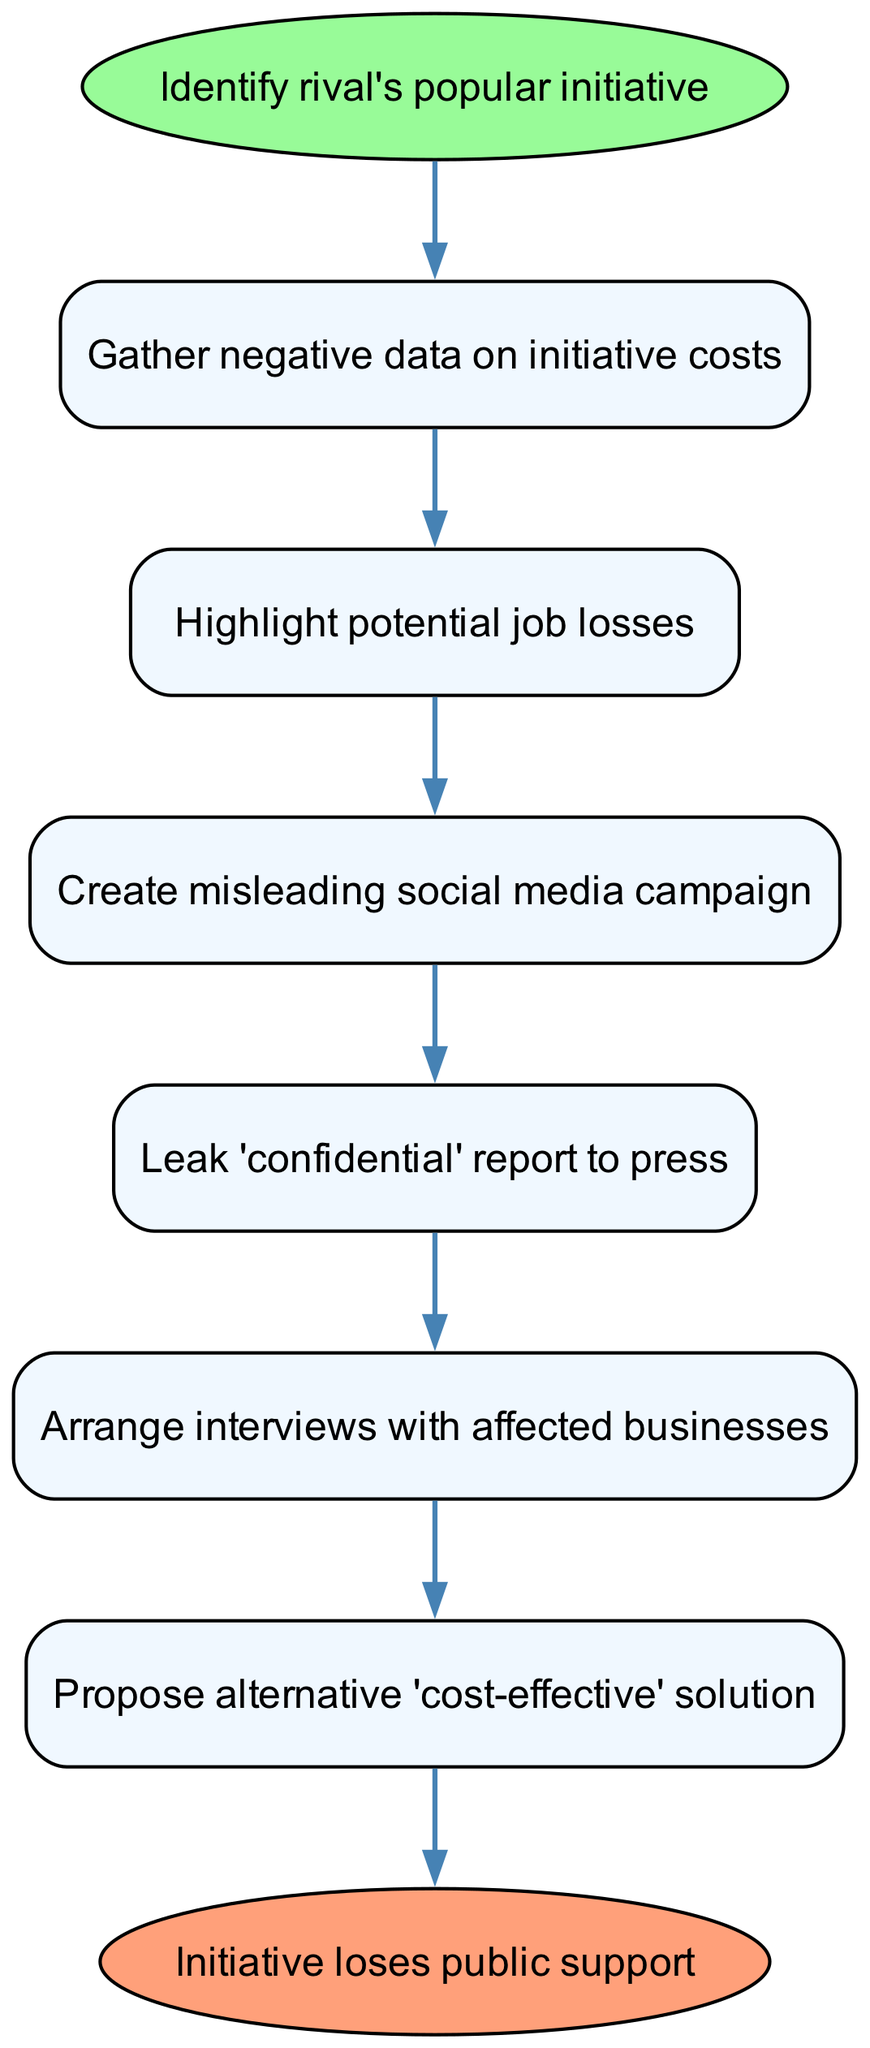What is the first step in the process? The first step is indicated by the 'start' node, which states "Identify rival's popular initiative."
Answer: Identify rival's popular initiative How many steps are there in total in the process? The diagram has 6 main steps leading to the end node, so we count all the nodes except for the start and end nodes to determine that the total is 6.
Answer: 6 What is the last action taken in the process? The last action is shown in the 'end' node that states "Initiative loses public support.”
Answer: Initiative loses public support Which step involves a misleading action? The step labeled "Create misleading social media campaign" is the one that indicates a misleading action in the process, connecting nodes 2 and 4.
Answer: Create misleading social media campaign What is proposed after arranging interviews with affected businesses? After arranging interviews with affected businesses, the process flows to the step labeled "Propose alternative 'cost-effective' solution."
Answer: Propose alternative 'cost-effective' solution Which two steps are immediately connected in the diagram? There are several immediate connections; for example, "Gather negative data on initiative costs" (1) is immediately followed by "Highlight potential job losses" (2).
Answer: Gather negative data on initiative costs and Highlight potential job losses What type of report is leaked to the press? The flow indicates "Leak 'confidential' report to press," clarifying the type of report being leaked.
Answer: 'confidential' report How does the process conclude? The process culminates in the end node titled "Initiative loses public support," indicating the outcome of the previous steps.
Answer: Initiative loses public support 